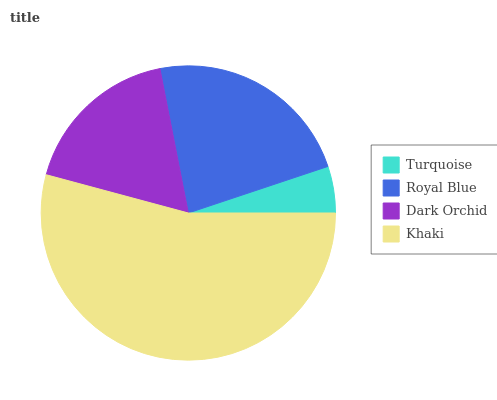Is Turquoise the minimum?
Answer yes or no. Yes. Is Khaki the maximum?
Answer yes or no. Yes. Is Royal Blue the minimum?
Answer yes or no. No. Is Royal Blue the maximum?
Answer yes or no. No. Is Royal Blue greater than Turquoise?
Answer yes or no. Yes. Is Turquoise less than Royal Blue?
Answer yes or no. Yes. Is Turquoise greater than Royal Blue?
Answer yes or no. No. Is Royal Blue less than Turquoise?
Answer yes or no. No. Is Royal Blue the high median?
Answer yes or no. Yes. Is Dark Orchid the low median?
Answer yes or no. Yes. Is Dark Orchid the high median?
Answer yes or no. No. Is Turquoise the low median?
Answer yes or no. No. 